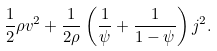Convert formula to latex. <formula><loc_0><loc_0><loc_500><loc_500>\frac { 1 } { 2 } \rho v ^ { 2 } + \frac { 1 } { 2 \rho } \left ( \frac { 1 } { \psi } + \frac { 1 } { 1 - \psi } \right ) j ^ { 2 } .</formula> 